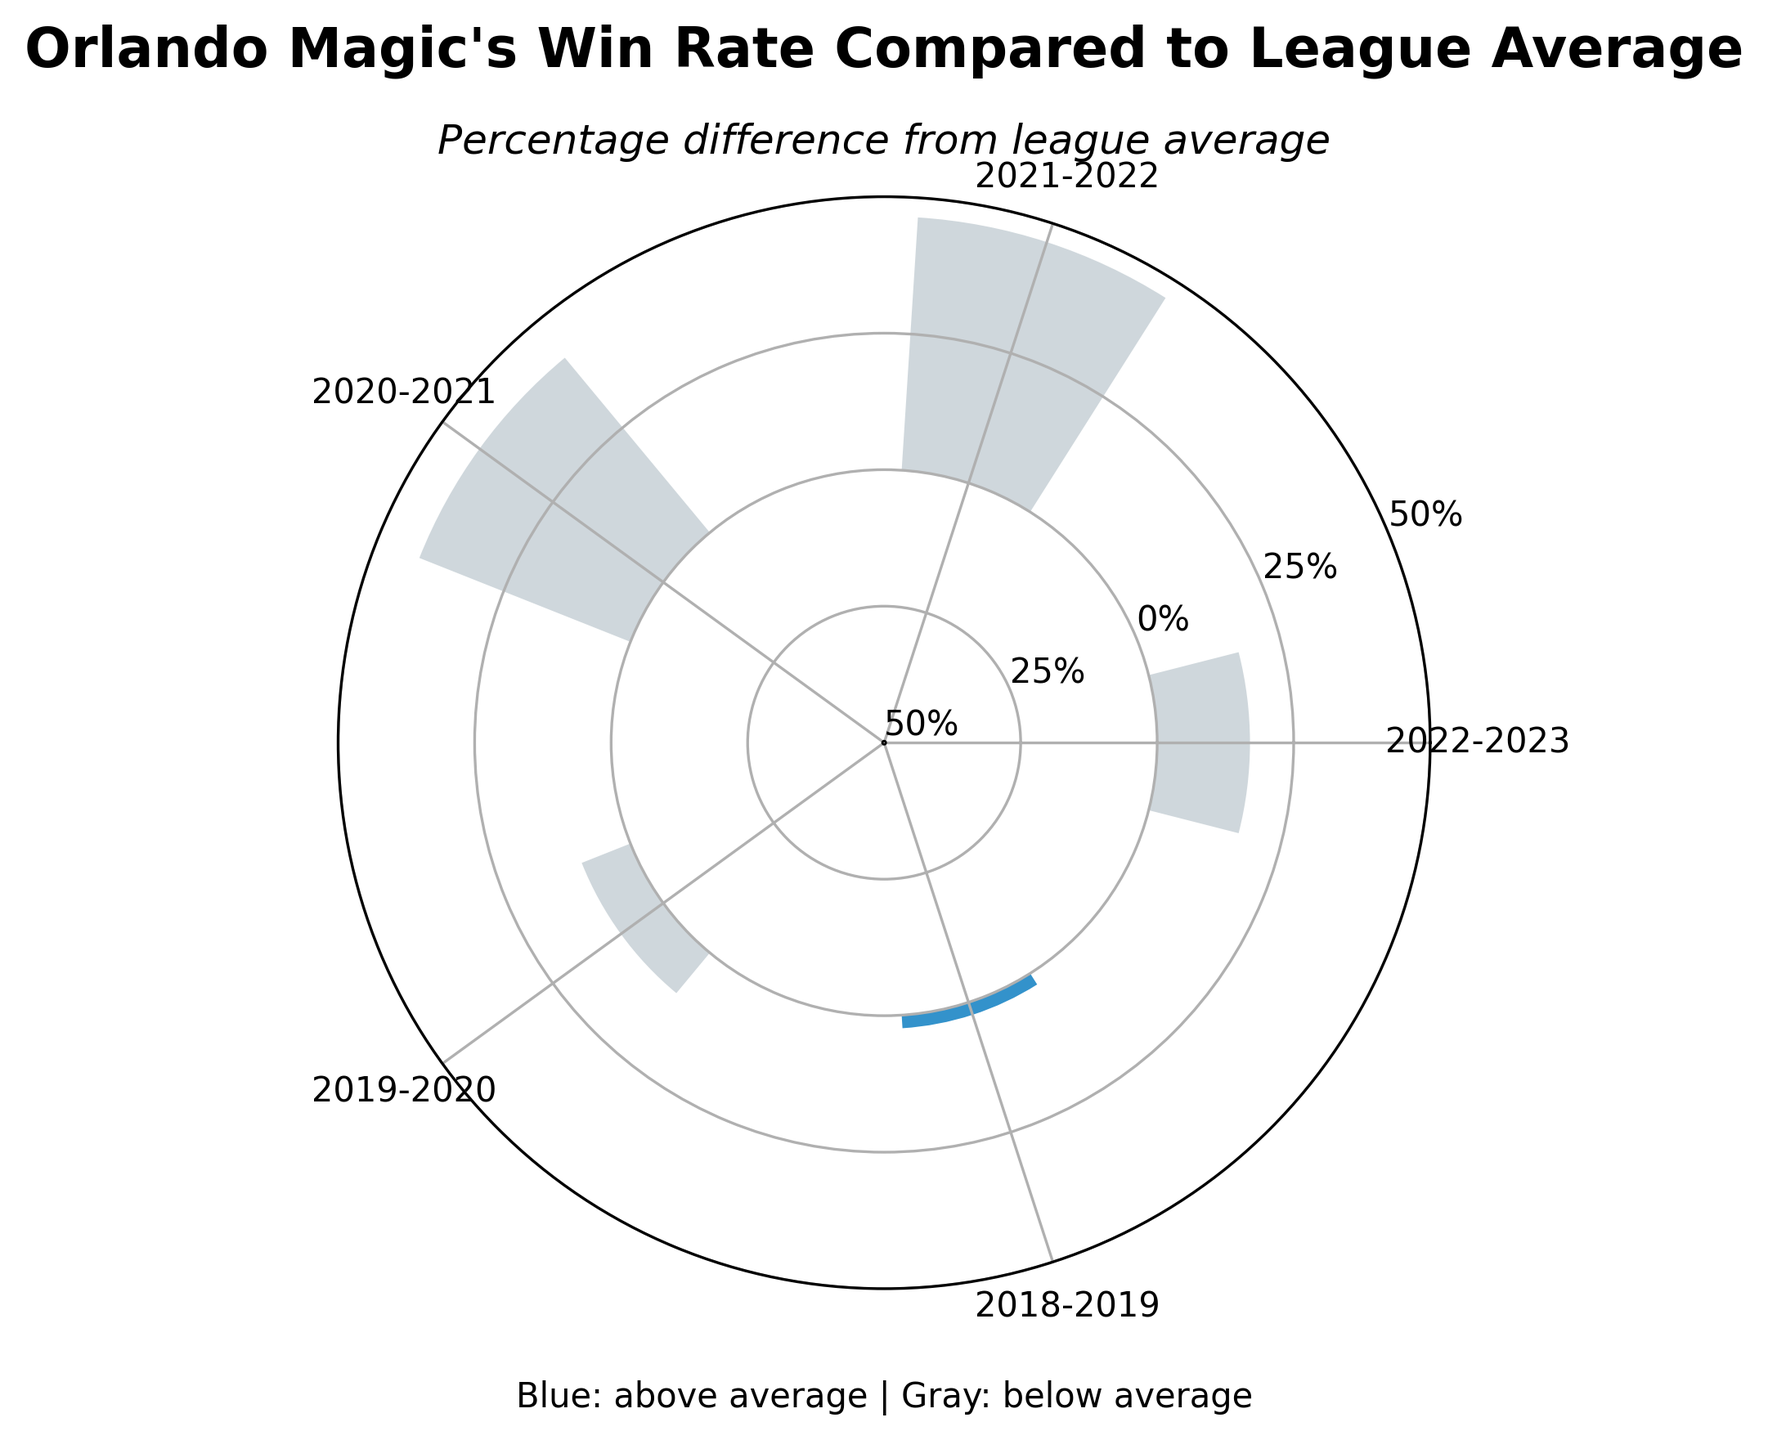What's the title of the figure? The title of the figure is usually found at the top, emphasizing the main topic or data being represented in the figure.
Answer: Orlando Magic's Win Rate Compared to League Average What does the gray color represent in the plot? According to the explanatory text present in the plot, the gray color indicates that the percentage difference is below average.
Answer: below average What season had the highest win rate compared to the league average? By examining the angle plot (the angles represent different seasons), we can see which bar extends furthest above the center circle in blue, indicating the highest percentage difference above average. The season with the largest positive blue bar is higher.
Answer: 2018-2019 What's the percentage difference in win rate for the 2019-2020 season? Looking at the bar corresponding to the 2019-2020 season's angle, we see how high the bar extends. This height indicates the percentage difference in win rate for that season. It is slightly below 0%, indicating a small negative difference from the league average.
Answer: -9.6% Which seasons had win rates below the league average and how can you tell? We identify seasons with gray bars, indicating they are below the league average. These bars extend negatively from the center circle. The respective seasons are 2022-2023, 2021-2022, 2020-2021, and 2019-2020.
Answer: 2022-2023, 2021-2022, 2020-2021, 2019-2020 What is the range of percentage differences shown on the plot? The y-axis of the plot is labeled with percentage differences, ranging from minimum and maximum values, -50% to 50%.
Answer: -50% to 50% Which season had the largest drop in win rate compared to the previous season? Examine the angles and heights of the bars; measure the difference in the height of bars in consecutive seasons. The comparison suggests the season with the most significant negative change. The 2022-2023 bar height dropped significantly compared to the previous year's 2021-2022 bar.
Answer: 2022-2023 How many seasons recorded a win rate equal to or above the league average? Count the number of blue bars that are positive, indicating win rates at or above the league average.
Answer: 1 